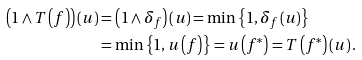<formula> <loc_0><loc_0><loc_500><loc_500>\left ( 1 \wedge T \left ( f \right ) \right ) \left ( u \right ) & = \left ( 1 \wedge \delta _ { f } \right ) \left ( u \right ) = \min \left \{ 1 , \delta _ { f } \left ( u \right ) \right \} \\ & = \min \left \{ 1 , u \left ( f \right ) \right \} = u \left ( f ^ { \ast } \right ) = T \left ( f ^ { \ast } \right ) \left ( u \right ) .</formula> 